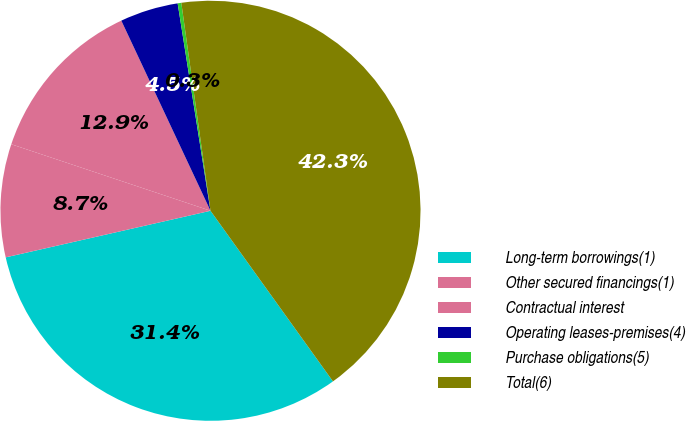Convert chart. <chart><loc_0><loc_0><loc_500><loc_500><pie_chart><fcel>Long-term borrowings(1)<fcel>Other secured financings(1)<fcel>Contractual interest<fcel>Operating leases-premises(4)<fcel>Purchase obligations(5)<fcel>Total(6)<nl><fcel>31.35%<fcel>8.69%<fcel>12.89%<fcel>4.48%<fcel>0.28%<fcel>42.31%<nl></chart> 